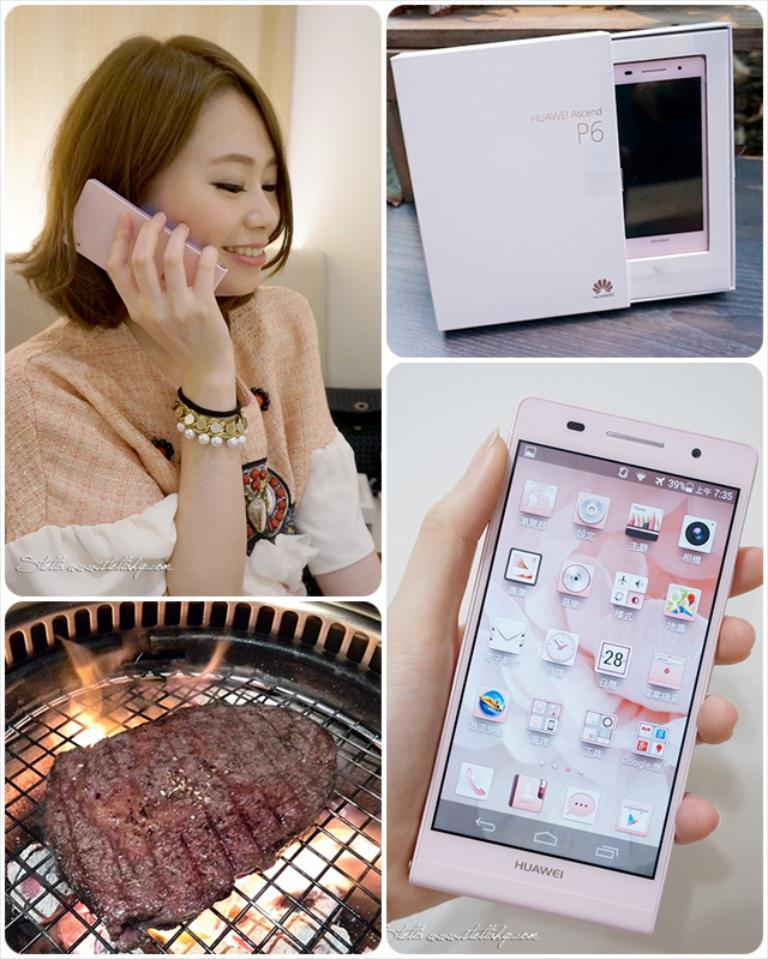What is the person in the left top image doing? The person in the left top image is talking on the phone. What can be seen below the person talking on the phone? There is meat in the image below the person talking on the phone. What is located in the right top image? There is a phone box in the right top image. What is present in the image below the phone box? There is a phone in the image below the phone box. Can you tell me how many quinces are on the phone in the image? There are no quinces present in the image; the image only features a person talking on the phone, meat, a phone box, and a phone. Is the person talking on the phone wearing a tramp outfit? There is no information about the person's clothing in the image, so it cannot be determined if they are wearing a tramp outfit. 